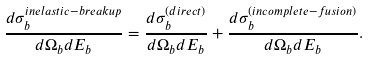<formula> <loc_0><loc_0><loc_500><loc_500>\frac { d \sigma _ { b } ^ { i n e l a s t i c - b r e a k u p } } { d \Omega _ { b } d E _ { b } } = \frac { d \sigma _ { b } ^ { ( d i r e c t ) } } { d \Omega _ { b } d E _ { b } } + \frac { d \sigma _ { b } ^ { ( i n c o m p l e t e - f u s i o n ) } } { d \Omega _ { b } d E _ { b } } .</formula> 